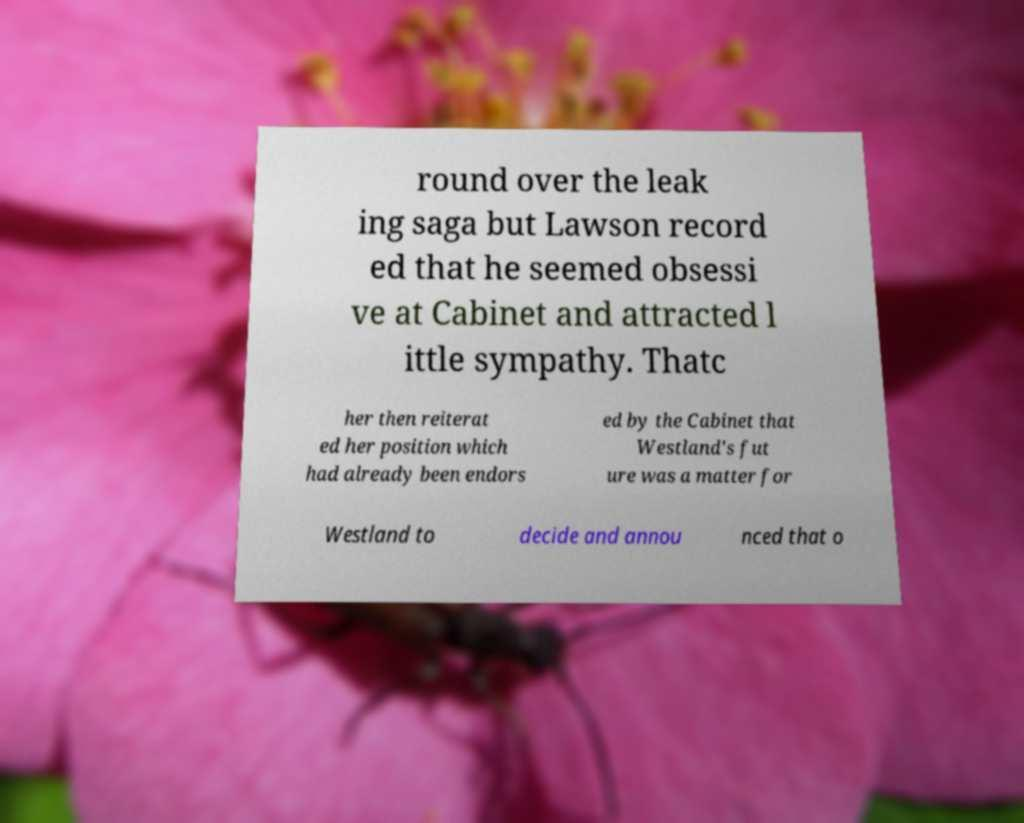I need the written content from this picture converted into text. Can you do that? round over the leak ing saga but Lawson record ed that he seemed obsessi ve at Cabinet and attracted l ittle sympathy. Thatc her then reiterat ed her position which had already been endors ed by the Cabinet that Westland's fut ure was a matter for Westland to decide and annou nced that o 